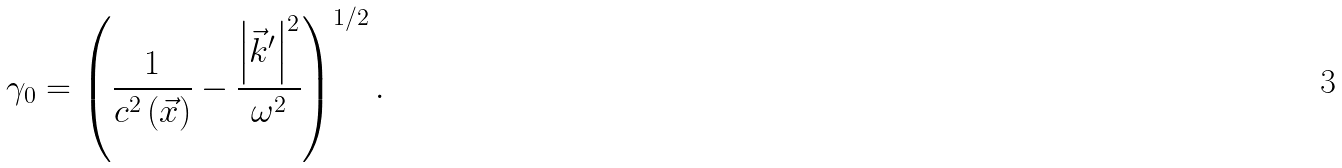<formula> <loc_0><loc_0><loc_500><loc_500>\gamma _ { 0 } = \left ( \frac { 1 } { c ^ { 2 } \left ( { \vec { x } } \right ) } - \frac { \left | { \vec { k } } ^ { \prime } \right | ^ { 2 } } { \omega ^ { 2 } } \right ) ^ { 1 / 2 } .</formula> 